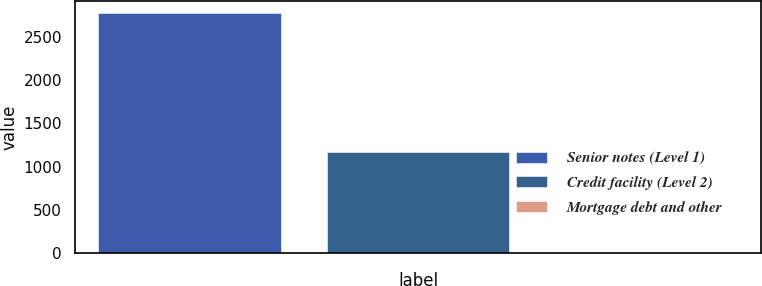<chart> <loc_0><loc_0><loc_500><loc_500><bar_chart><fcel>Senior notes (Level 1)<fcel>Credit facility (Level 2)<fcel>Mortgage debt and other<nl><fcel>2778<fcel>1170<fcel>5<nl></chart> 